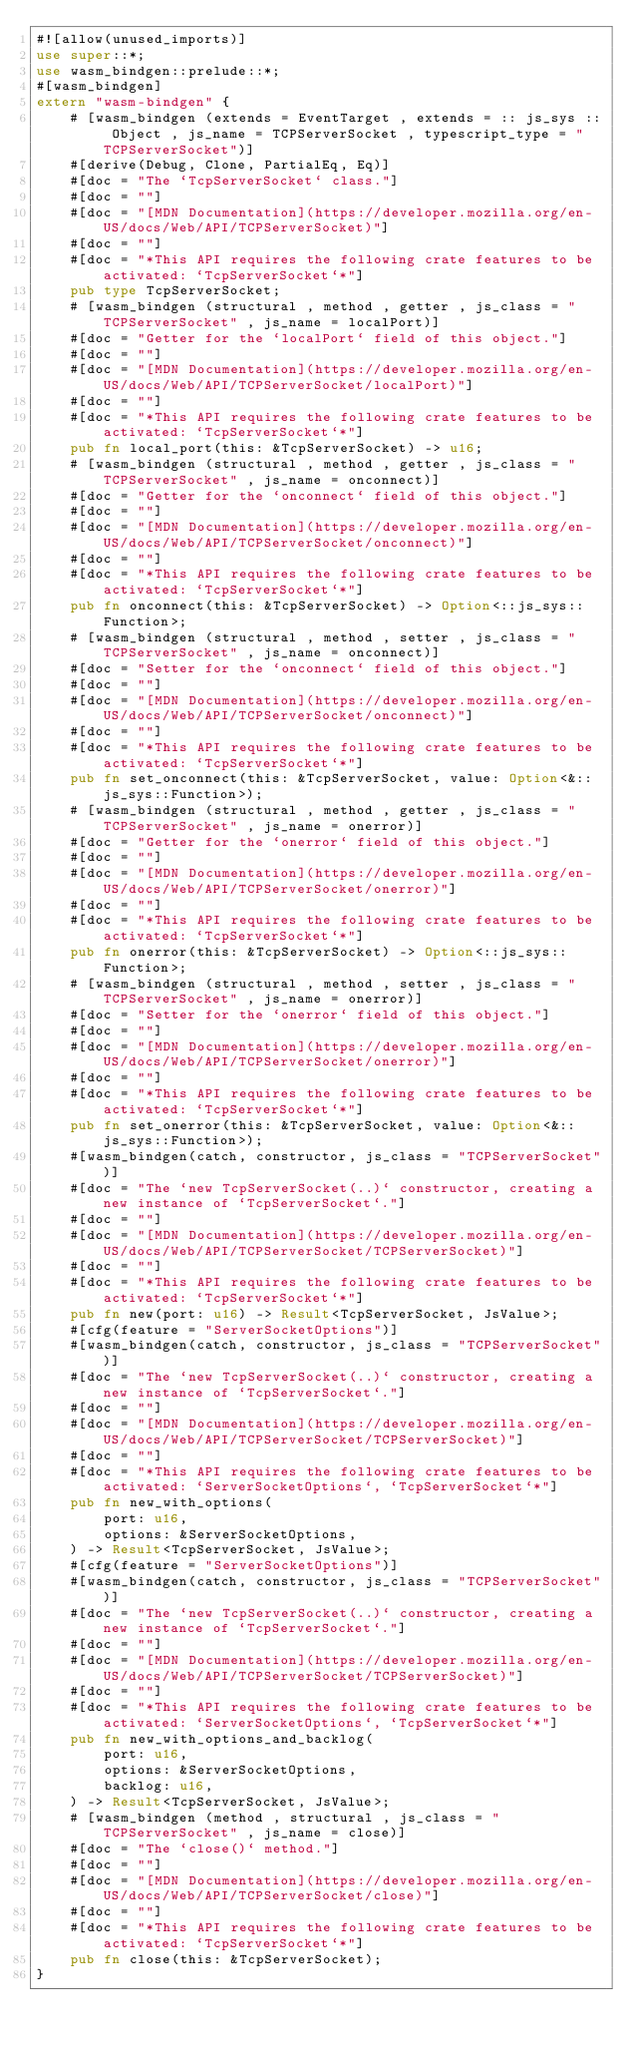Convert code to text. <code><loc_0><loc_0><loc_500><loc_500><_Rust_>#![allow(unused_imports)]
use super::*;
use wasm_bindgen::prelude::*;
#[wasm_bindgen]
extern "wasm-bindgen" {
    # [wasm_bindgen (extends = EventTarget , extends = :: js_sys :: Object , js_name = TCPServerSocket , typescript_type = "TCPServerSocket")]
    #[derive(Debug, Clone, PartialEq, Eq)]
    #[doc = "The `TcpServerSocket` class."]
    #[doc = ""]
    #[doc = "[MDN Documentation](https://developer.mozilla.org/en-US/docs/Web/API/TCPServerSocket)"]
    #[doc = ""]
    #[doc = "*This API requires the following crate features to be activated: `TcpServerSocket`*"]
    pub type TcpServerSocket;
    # [wasm_bindgen (structural , method , getter , js_class = "TCPServerSocket" , js_name = localPort)]
    #[doc = "Getter for the `localPort` field of this object."]
    #[doc = ""]
    #[doc = "[MDN Documentation](https://developer.mozilla.org/en-US/docs/Web/API/TCPServerSocket/localPort)"]
    #[doc = ""]
    #[doc = "*This API requires the following crate features to be activated: `TcpServerSocket`*"]
    pub fn local_port(this: &TcpServerSocket) -> u16;
    # [wasm_bindgen (structural , method , getter , js_class = "TCPServerSocket" , js_name = onconnect)]
    #[doc = "Getter for the `onconnect` field of this object."]
    #[doc = ""]
    #[doc = "[MDN Documentation](https://developer.mozilla.org/en-US/docs/Web/API/TCPServerSocket/onconnect)"]
    #[doc = ""]
    #[doc = "*This API requires the following crate features to be activated: `TcpServerSocket`*"]
    pub fn onconnect(this: &TcpServerSocket) -> Option<::js_sys::Function>;
    # [wasm_bindgen (structural , method , setter , js_class = "TCPServerSocket" , js_name = onconnect)]
    #[doc = "Setter for the `onconnect` field of this object."]
    #[doc = ""]
    #[doc = "[MDN Documentation](https://developer.mozilla.org/en-US/docs/Web/API/TCPServerSocket/onconnect)"]
    #[doc = ""]
    #[doc = "*This API requires the following crate features to be activated: `TcpServerSocket`*"]
    pub fn set_onconnect(this: &TcpServerSocket, value: Option<&::js_sys::Function>);
    # [wasm_bindgen (structural , method , getter , js_class = "TCPServerSocket" , js_name = onerror)]
    #[doc = "Getter for the `onerror` field of this object."]
    #[doc = ""]
    #[doc = "[MDN Documentation](https://developer.mozilla.org/en-US/docs/Web/API/TCPServerSocket/onerror)"]
    #[doc = ""]
    #[doc = "*This API requires the following crate features to be activated: `TcpServerSocket`*"]
    pub fn onerror(this: &TcpServerSocket) -> Option<::js_sys::Function>;
    # [wasm_bindgen (structural , method , setter , js_class = "TCPServerSocket" , js_name = onerror)]
    #[doc = "Setter for the `onerror` field of this object."]
    #[doc = ""]
    #[doc = "[MDN Documentation](https://developer.mozilla.org/en-US/docs/Web/API/TCPServerSocket/onerror)"]
    #[doc = ""]
    #[doc = "*This API requires the following crate features to be activated: `TcpServerSocket`*"]
    pub fn set_onerror(this: &TcpServerSocket, value: Option<&::js_sys::Function>);
    #[wasm_bindgen(catch, constructor, js_class = "TCPServerSocket")]
    #[doc = "The `new TcpServerSocket(..)` constructor, creating a new instance of `TcpServerSocket`."]
    #[doc = ""]
    #[doc = "[MDN Documentation](https://developer.mozilla.org/en-US/docs/Web/API/TCPServerSocket/TCPServerSocket)"]
    #[doc = ""]
    #[doc = "*This API requires the following crate features to be activated: `TcpServerSocket`*"]
    pub fn new(port: u16) -> Result<TcpServerSocket, JsValue>;
    #[cfg(feature = "ServerSocketOptions")]
    #[wasm_bindgen(catch, constructor, js_class = "TCPServerSocket")]
    #[doc = "The `new TcpServerSocket(..)` constructor, creating a new instance of `TcpServerSocket`."]
    #[doc = ""]
    #[doc = "[MDN Documentation](https://developer.mozilla.org/en-US/docs/Web/API/TCPServerSocket/TCPServerSocket)"]
    #[doc = ""]
    #[doc = "*This API requires the following crate features to be activated: `ServerSocketOptions`, `TcpServerSocket`*"]
    pub fn new_with_options(
        port: u16,
        options: &ServerSocketOptions,
    ) -> Result<TcpServerSocket, JsValue>;
    #[cfg(feature = "ServerSocketOptions")]
    #[wasm_bindgen(catch, constructor, js_class = "TCPServerSocket")]
    #[doc = "The `new TcpServerSocket(..)` constructor, creating a new instance of `TcpServerSocket`."]
    #[doc = ""]
    #[doc = "[MDN Documentation](https://developer.mozilla.org/en-US/docs/Web/API/TCPServerSocket/TCPServerSocket)"]
    #[doc = ""]
    #[doc = "*This API requires the following crate features to be activated: `ServerSocketOptions`, `TcpServerSocket`*"]
    pub fn new_with_options_and_backlog(
        port: u16,
        options: &ServerSocketOptions,
        backlog: u16,
    ) -> Result<TcpServerSocket, JsValue>;
    # [wasm_bindgen (method , structural , js_class = "TCPServerSocket" , js_name = close)]
    #[doc = "The `close()` method."]
    #[doc = ""]
    #[doc = "[MDN Documentation](https://developer.mozilla.org/en-US/docs/Web/API/TCPServerSocket/close)"]
    #[doc = ""]
    #[doc = "*This API requires the following crate features to be activated: `TcpServerSocket`*"]
    pub fn close(this: &TcpServerSocket);
}
</code> 